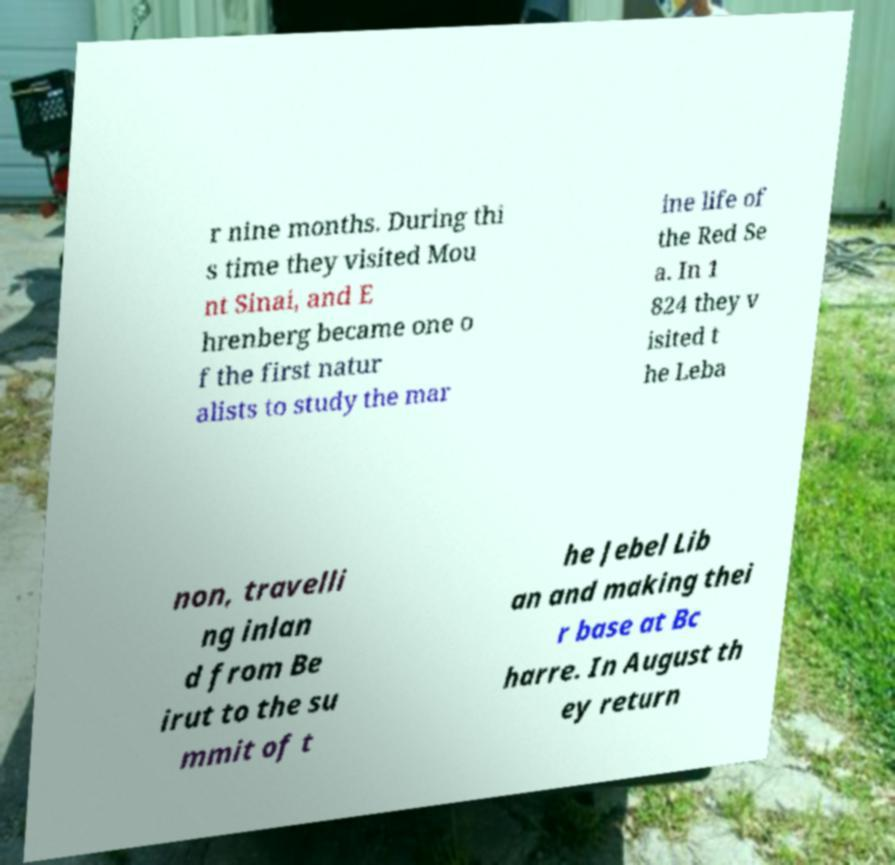What messages or text are displayed in this image? I need them in a readable, typed format. r nine months. During thi s time they visited Mou nt Sinai, and E hrenberg became one o f the first natur alists to study the mar ine life of the Red Se a. In 1 824 they v isited t he Leba non, travelli ng inlan d from Be irut to the su mmit of t he Jebel Lib an and making thei r base at Bc harre. In August th ey return 